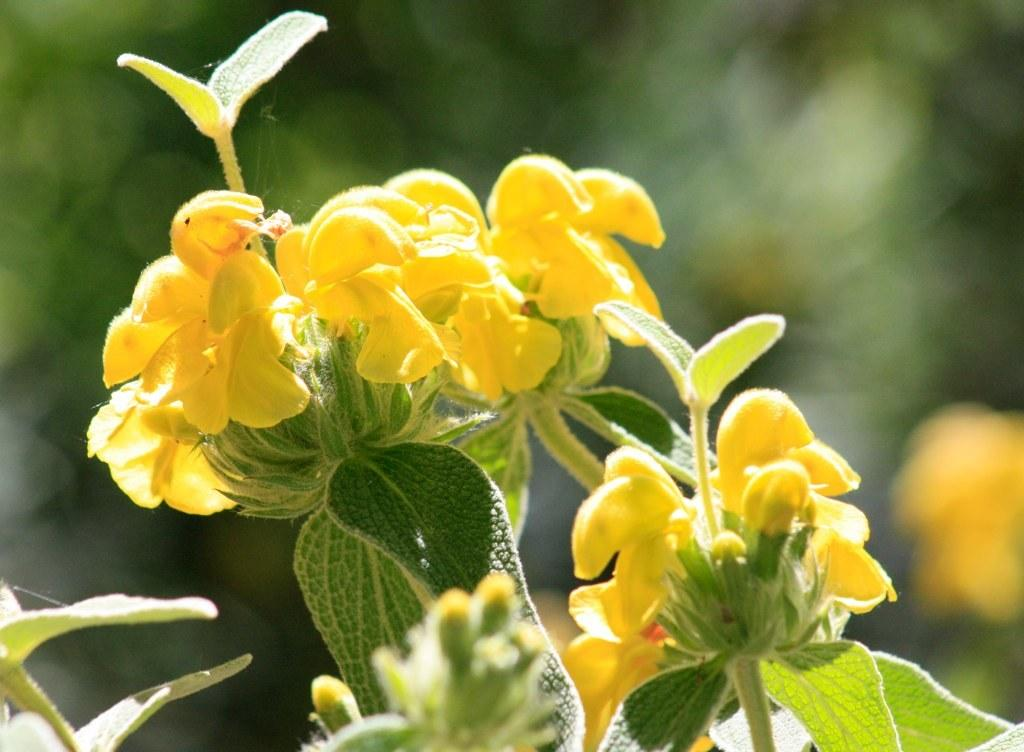What is present in the image? There is a plant in the image. What can be observed about the plant? The plant has flowers. What is the color of the flowers? The flowers are yellow in color. Is the grandfather sitting next to the plant in the image? There is no mention of a grandfather in the provided facts, and therefore we cannot determine if he is present in the image. 